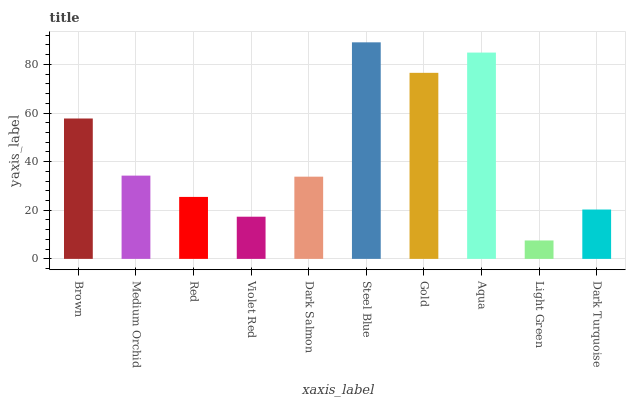Is Light Green the minimum?
Answer yes or no. Yes. Is Steel Blue the maximum?
Answer yes or no. Yes. Is Medium Orchid the minimum?
Answer yes or no. No. Is Medium Orchid the maximum?
Answer yes or no. No. Is Brown greater than Medium Orchid?
Answer yes or no. Yes. Is Medium Orchid less than Brown?
Answer yes or no. Yes. Is Medium Orchid greater than Brown?
Answer yes or no. No. Is Brown less than Medium Orchid?
Answer yes or no. No. Is Medium Orchid the high median?
Answer yes or no. Yes. Is Dark Salmon the low median?
Answer yes or no. Yes. Is Brown the high median?
Answer yes or no. No. Is Violet Red the low median?
Answer yes or no. No. 